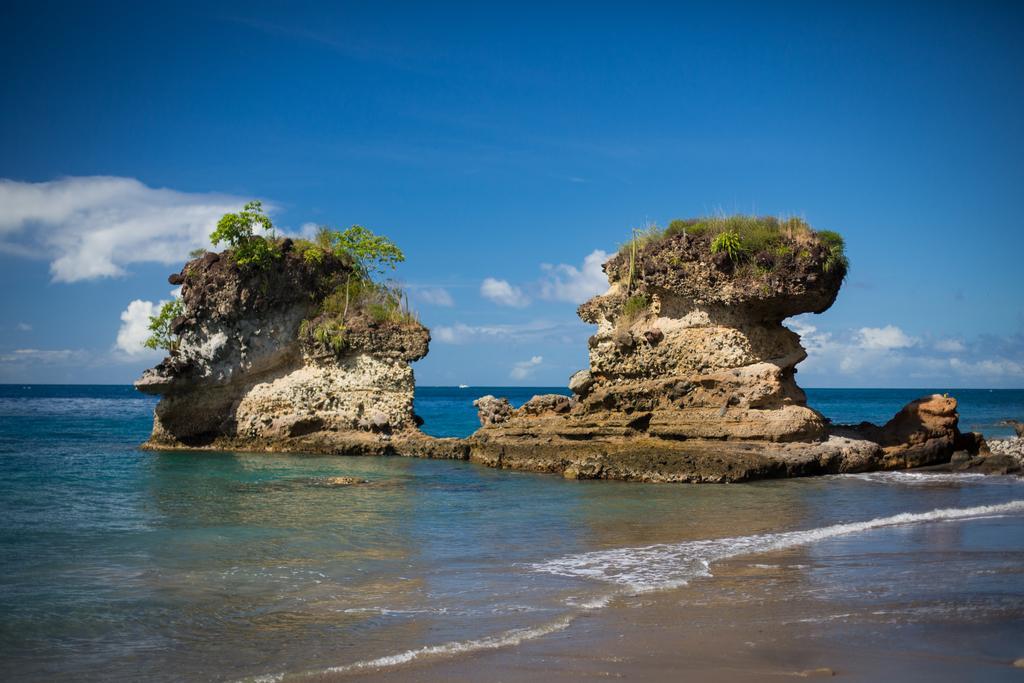Describe this image in one or two sentences. This is the picture of a sea. In the foreground it looks like a hill and there are trees on the hill. At the top there is sky and there are clouds. At the bottom there is water and sand. 